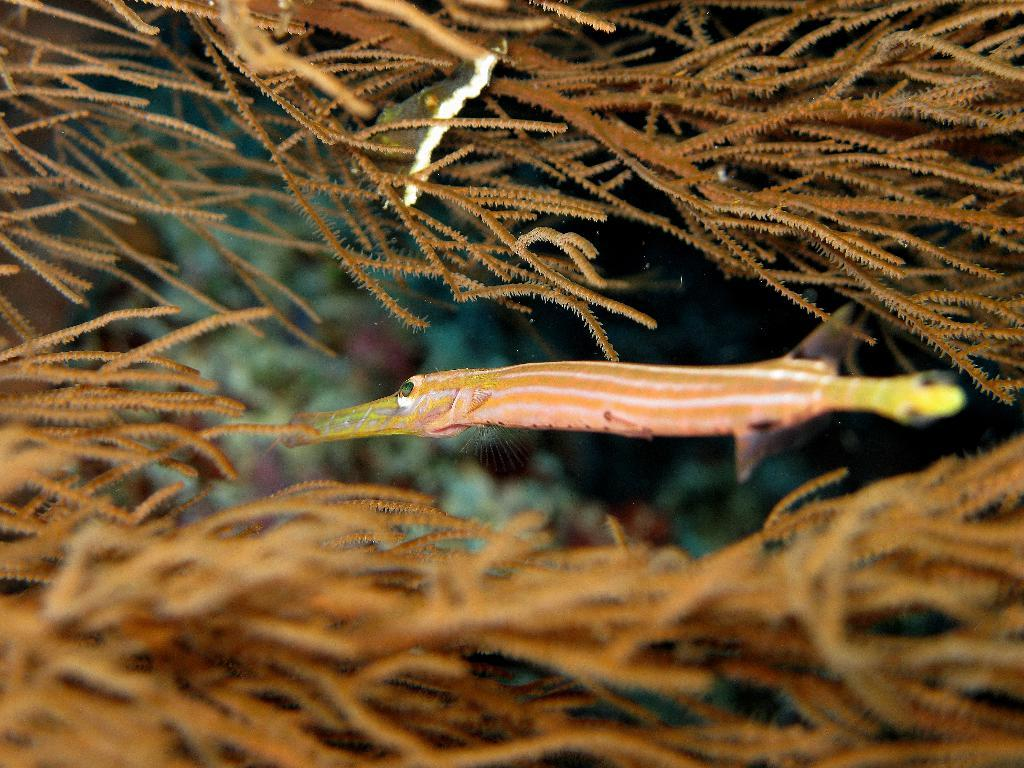What is the primary element in the image? There is water in the image. What type of animal can be seen in the water? There is a fish in the image. What other living organisms are present in the water? There are marine plants in the image. How many balls can be seen bouncing in the water in the image? There are no balls present in the image; it features water, a fish, and marine plants. 